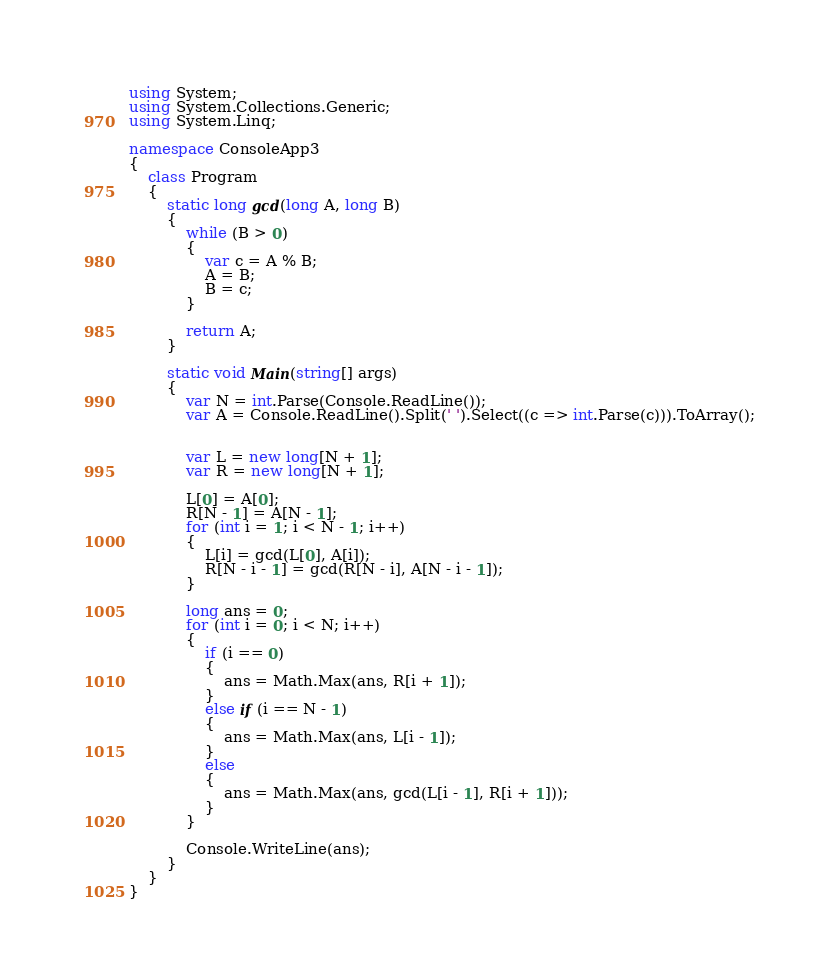Convert code to text. <code><loc_0><loc_0><loc_500><loc_500><_C#_>using System;
using System.Collections.Generic;
using System.Linq;

namespace ConsoleApp3
{
    class Program
    {
        static long gcd(long A, long B)
        {
            while (B > 0)
            {
                var c = A % B;
                A = B;
                B = c;
            }

            return A;
        }

        static void Main(string[] args)
        {
            var N = int.Parse(Console.ReadLine());
            var A = Console.ReadLine().Split(' ').Select((c => int.Parse(c))).ToArray();


            var L = new long[N + 1];
            var R = new long[N + 1];

            L[0] = A[0];
            R[N - 1] = A[N - 1];
            for (int i = 1; i < N - 1; i++)
            {
                L[i] = gcd(L[0], A[i]);
                R[N - i - 1] = gcd(R[N - i], A[N - i - 1]);
            }

            long ans = 0;
            for (int i = 0; i < N; i++)
            {
                if (i == 0)
                {
                    ans = Math.Max(ans, R[i + 1]);
                }
                else if (i == N - 1)
                {
                    ans = Math.Max(ans, L[i - 1]);
                }
                else
                {
                    ans = Math.Max(ans, gcd(L[i - 1], R[i + 1]));
                }
            }

            Console.WriteLine(ans);
        }
    }
}</code> 